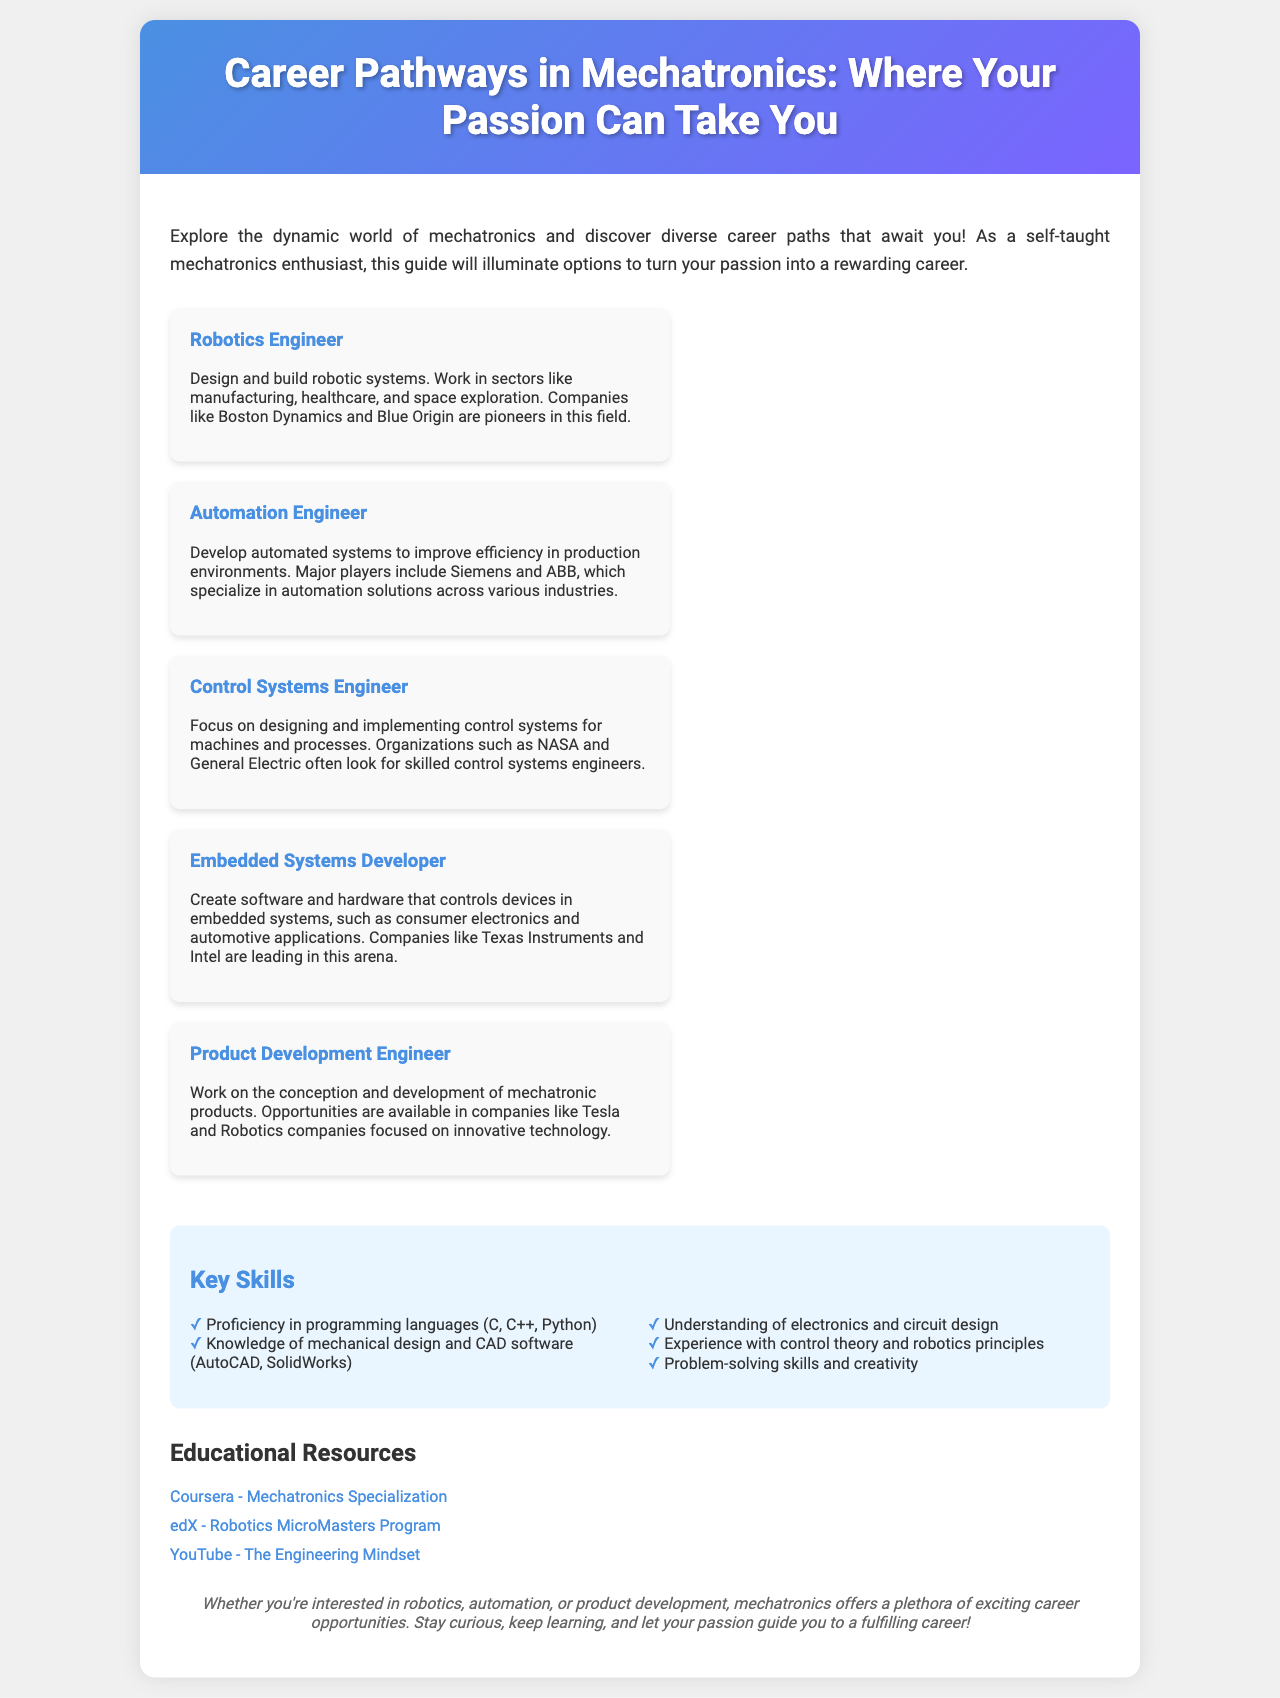What is the title of the brochure? The title is stated prominently in the header section of the brochure.
Answer: Career Pathways in Mechatronics: Where Your Passion Can Take You Which career option focuses on designing robotic systems? This information is found in the career options section where various careers are listed.
Answer: Robotics Engineer Name a company that specializes in automation solutions. The document lists companies associated with each career, including automation engineering firms.
Answer: Siemens What skill is related to programming languages? Key skills are highlighted, and one specifically mentions programming.
Answer: Proficiency in programming languages (C, C++, Python) What educational resource offers a Mechatronics Specialization? There are listed educational resources that provide specific programs related to mechatronics.
Answer: Coursera How many main career options are presented in the brochure? The brochure lists the different careers in the mechatronics field.
Answer: Five Which engineering role involves the development of mechatronic products? The specific role related to product development is mentioned in the brochure.
Answer: Product Development Engineer Where can you find the "YouTube - The Engineering Mindset" resource? The educational resources section provides links to various platforms.
Answer: YouTube What type of skills are emphasized in the skills section? The skills section lists important abilities needed in mechatronics.
Answer: Key Skills 